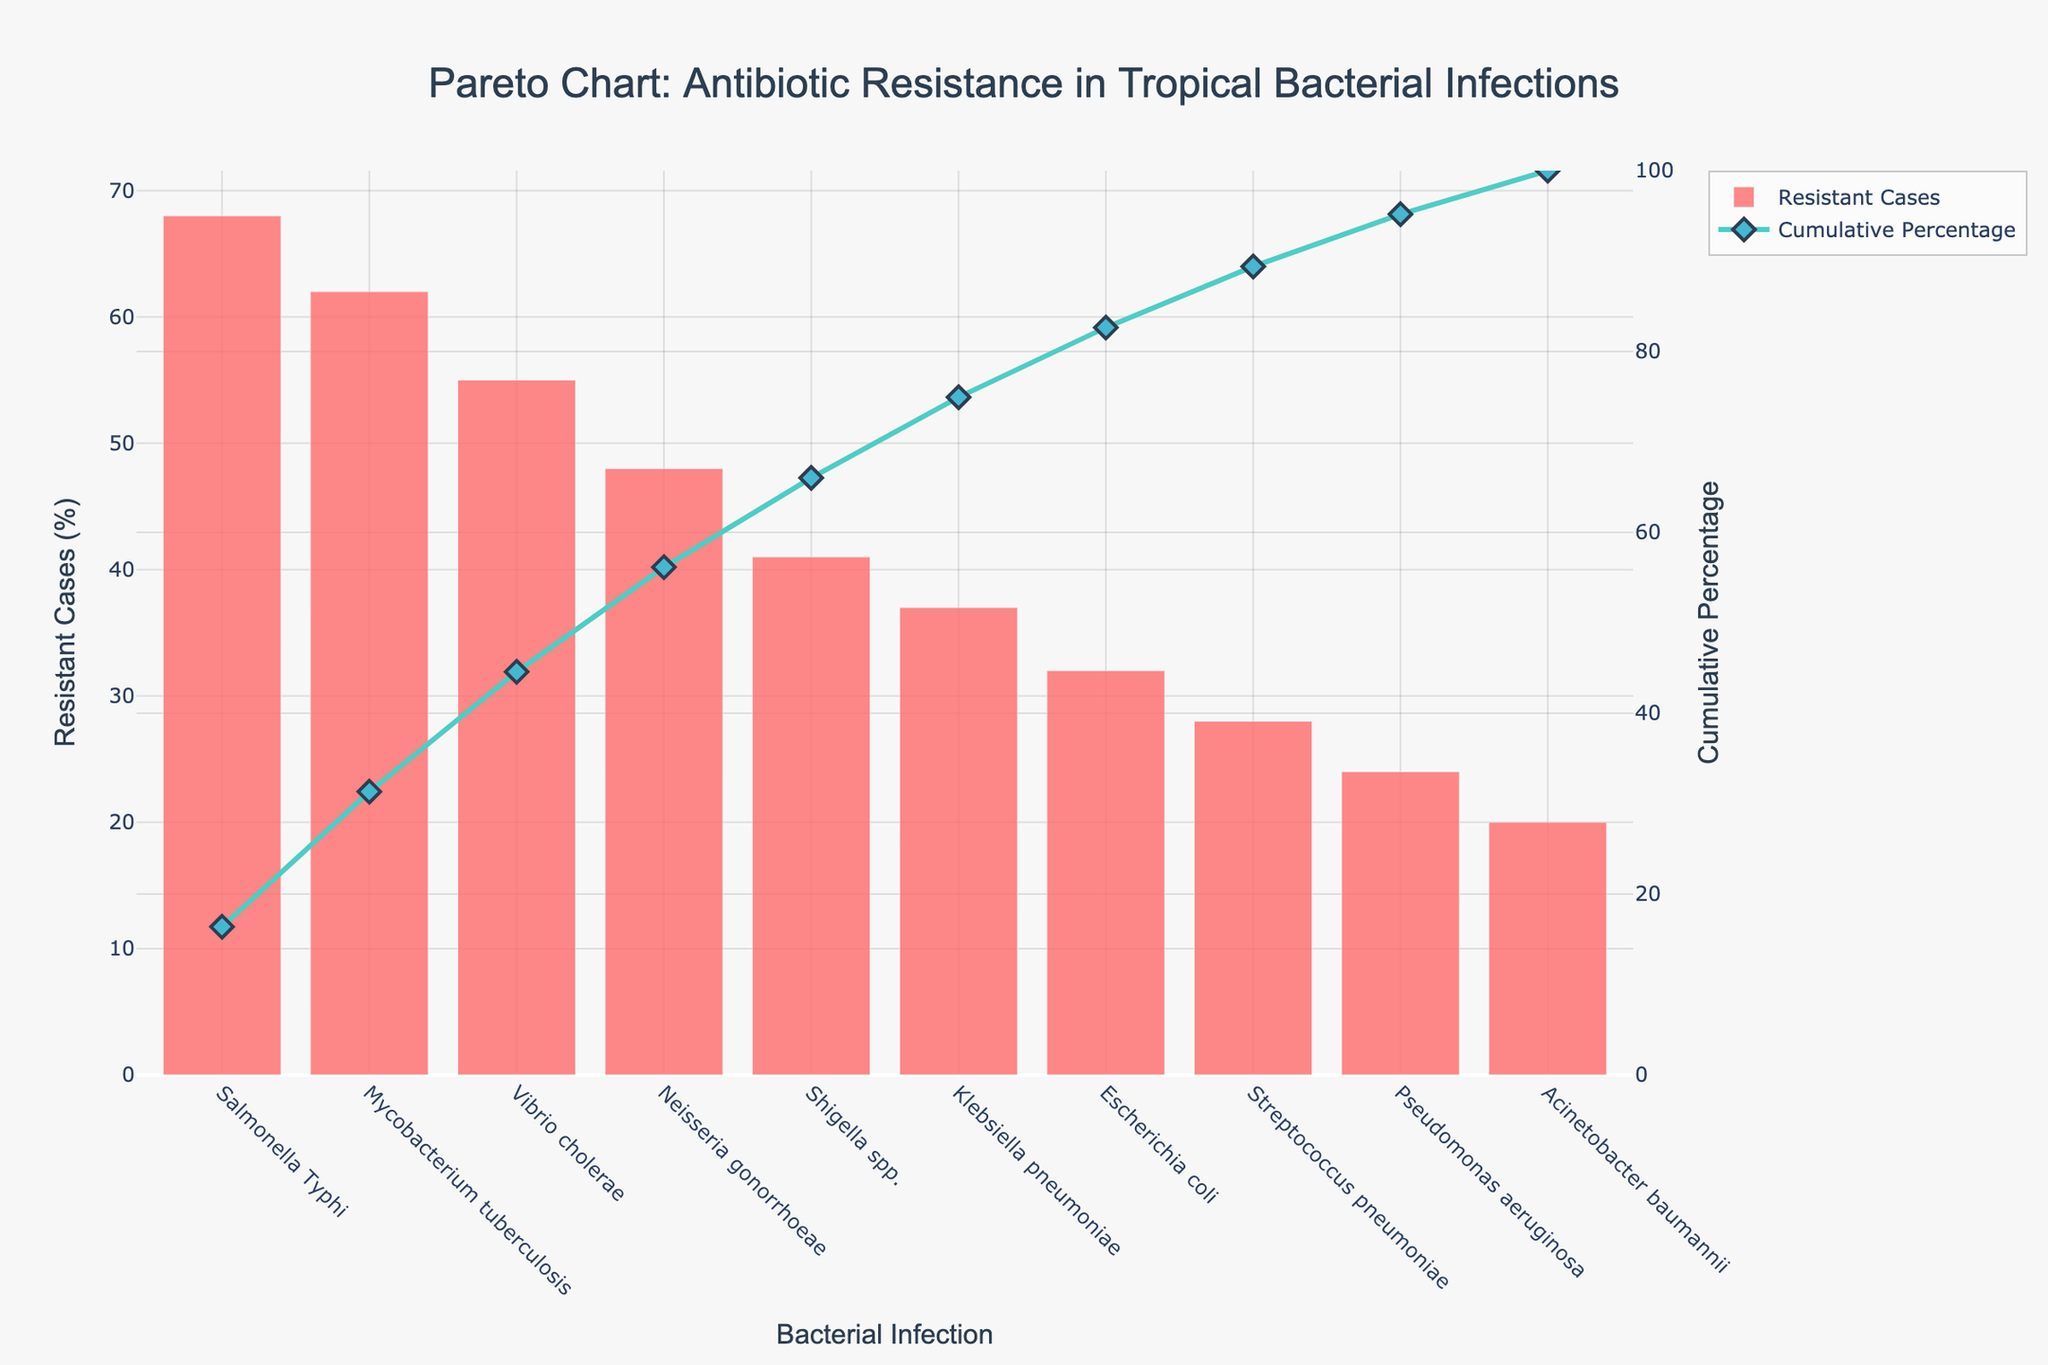Which bacterial infection has the highest percentage of resistant cases? The figure shows the percentage of resistant cases for each bacterial infection. The bar corresponding to Salmonella Typhi is the tallest.
Answer: Salmonella Typhi What's the cumulative percentage of resistance up to Mycobacterium tuberculosis? The cumulative percentage line indicates cumulative resistance, reaching about 68% at Mycobacterium tuberculosis.
Answer: 68% How many bacterial infections have a resistance percentage of 40% or higher? By counting the bars equal to or taller than the one marked at 40%, we have Salmonella Typhi, Mycobacterium tuberculosis, Vibrio cholerae, Neisseria gonorrhoeae, and Shigella spp.
Answer: 5 Compare the resistance of Escherichia coli and Klebsiella pneumoniae. Which one has a higher percentage? Klebsiella pneumoniae has a taller bar than Escherichia coli.
Answer: Klebsiella pneumoniae What's the percentage difference in resistance between Neisseria gonorrhoeae and Shigella spp.? Neisseria gonorrhoeae has 48% and Shigella spp. has 41%; the difference is 48 - 41 = 7%.
Answer: 7% How much of the cumulative percentage do Salmonella Typhi and Mycobacterium tuberculosis together contribute? Add their individual resistance percentages: 68% + 62% = 130%. Then, refer to the sum of all the resistance percentages, set it as the denominator to calculate the cumulative percentage: 68% + 62% = 130% / 415 (sum of individual percentages) x 100 = 31.3%.
Answer: 31.3% Is the resistance of Pseudomonas aeruginosa greater than that of Streptococcus pneumoniae? The height of the Pseudomonas aeruginosa bar is shorter than that of Streptococcus pneumoniae.
Answer: No What's the ratio of resistant cases of Klebsiella pneumoniae to Acinetobacter baumannii? Klebsiella pneumoniae has a percentage of 37%, and Acinetobacter baumannii has 20%. The ratio is 37 / 20 = 1.85.
Answer: 1.85 Which bacterial infections contribute to 80% cumulative resistance? Follow the cumulative percentage line and find where it crosses 80%. Salmonella Typhi, Mycobacterium tuberculosis, Vibrio cholerae, Neisseria gonorrhoeae, and part of Shigella spp. contribute to up to around 80%.
Answer: Salmonella Typhi, Mycobacterium tuberculosis, Vibrio cholerae, Neisseria gonorrhoeae, Shigella spp 